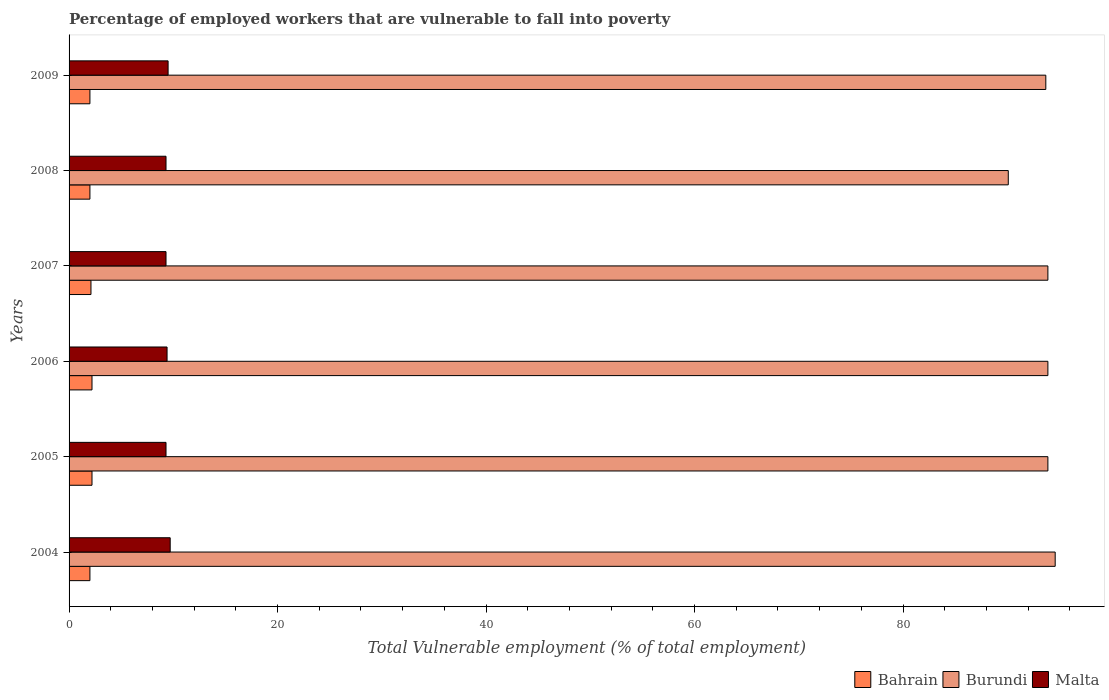How many groups of bars are there?
Your answer should be compact. 6. Are the number of bars on each tick of the Y-axis equal?
Your answer should be compact. Yes. How many bars are there on the 2nd tick from the top?
Provide a succinct answer. 3. How many bars are there on the 3rd tick from the bottom?
Provide a succinct answer. 3. What is the label of the 3rd group of bars from the top?
Offer a very short reply. 2007. In how many cases, is the number of bars for a given year not equal to the number of legend labels?
Provide a succinct answer. 0. Across all years, what is the maximum percentage of employed workers who are vulnerable to fall into poverty in Burundi?
Provide a succinct answer. 94.6. In which year was the percentage of employed workers who are vulnerable to fall into poverty in Malta maximum?
Give a very brief answer. 2004. What is the total percentage of employed workers who are vulnerable to fall into poverty in Malta in the graph?
Offer a very short reply. 56.5. What is the difference between the percentage of employed workers who are vulnerable to fall into poverty in Bahrain in 2008 and that in 2009?
Offer a terse response. 0. What is the difference between the percentage of employed workers who are vulnerable to fall into poverty in Burundi in 2004 and the percentage of employed workers who are vulnerable to fall into poverty in Bahrain in 2005?
Offer a very short reply. 92.4. What is the average percentage of employed workers who are vulnerable to fall into poverty in Malta per year?
Your answer should be compact. 9.42. In the year 2004, what is the difference between the percentage of employed workers who are vulnerable to fall into poverty in Burundi and percentage of employed workers who are vulnerable to fall into poverty in Malta?
Provide a short and direct response. 84.9. What is the ratio of the percentage of employed workers who are vulnerable to fall into poverty in Bahrain in 2004 to that in 2006?
Offer a terse response. 0.91. What is the difference between the highest and the second highest percentage of employed workers who are vulnerable to fall into poverty in Burundi?
Ensure brevity in your answer.  0.7. What is the difference between the highest and the lowest percentage of employed workers who are vulnerable to fall into poverty in Bahrain?
Keep it short and to the point. 0.2. What does the 2nd bar from the top in 2004 represents?
Provide a succinct answer. Burundi. What does the 2nd bar from the bottom in 2006 represents?
Provide a succinct answer. Burundi. How many bars are there?
Give a very brief answer. 18. How many years are there in the graph?
Your answer should be compact. 6. Are the values on the major ticks of X-axis written in scientific E-notation?
Provide a short and direct response. No. Does the graph contain any zero values?
Make the answer very short. No. What is the title of the graph?
Your response must be concise. Percentage of employed workers that are vulnerable to fall into poverty. Does "United Arab Emirates" appear as one of the legend labels in the graph?
Keep it short and to the point. No. What is the label or title of the X-axis?
Offer a very short reply. Total Vulnerable employment (% of total employment). What is the Total Vulnerable employment (% of total employment) of Burundi in 2004?
Provide a succinct answer. 94.6. What is the Total Vulnerable employment (% of total employment) in Malta in 2004?
Offer a terse response. 9.7. What is the Total Vulnerable employment (% of total employment) in Bahrain in 2005?
Provide a succinct answer. 2.2. What is the Total Vulnerable employment (% of total employment) in Burundi in 2005?
Your response must be concise. 93.9. What is the Total Vulnerable employment (% of total employment) in Malta in 2005?
Your answer should be compact. 9.3. What is the Total Vulnerable employment (% of total employment) in Bahrain in 2006?
Your answer should be very brief. 2.2. What is the Total Vulnerable employment (% of total employment) in Burundi in 2006?
Ensure brevity in your answer.  93.9. What is the Total Vulnerable employment (% of total employment) of Malta in 2006?
Provide a succinct answer. 9.4. What is the Total Vulnerable employment (% of total employment) in Bahrain in 2007?
Give a very brief answer. 2.1. What is the Total Vulnerable employment (% of total employment) of Burundi in 2007?
Ensure brevity in your answer.  93.9. What is the Total Vulnerable employment (% of total employment) in Malta in 2007?
Make the answer very short. 9.3. What is the Total Vulnerable employment (% of total employment) in Burundi in 2008?
Make the answer very short. 90.1. What is the Total Vulnerable employment (% of total employment) in Malta in 2008?
Provide a succinct answer. 9.3. What is the Total Vulnerable employment (% of total employment) of Burundi in 2009?
Your response must be concise. 93.7. What is the Total Vulnerable employment (% of total employment) of Malta in 2009?
Your answer should be compact. 9.5. Across all years, what is the maximum Total Vulnerable employment (% of total employment) of Bahrain?
Provide a short and direct response. 2.2. Across all years, what is the maximum Total Vulnerable employment (% of total employment) in Burundi?
Provide a short and direct response. 94.6. Across all years, what is the maximum Total Vulnerable employment (% of total employment) of Malta?
Provide a succinct answer. 9.7. Across all years, what is the minimum Total Vulnerable employment (% of total employment) in Bahrain?
Your answer should be compact. 2. Across all years, what is the minimum Total Vulnerable employment (% of total employment) of Burundi?
Give a very brief answer. 90.1. Across all years, what is the minimum Total Vulnerable employment (% of total employment) of Malta?
Offer a terse response. 9.3. What is the total Total Vulnerable employment (% of total employment) in Burundi in the graph?
Offer a very short reply. 560.1. What is the total Total Vulnerable employment (% of total employment) of Malta in the graph?
Keep it short and to the point. 56.5. What is the difference between the Total Vulnerable employment (% of total employment) of Bahrain in 2004 and that in 2005?
Provide a succinct answer. -0.2. What is the difference between the Total Vulnerable employment (% of total employment) in Bahrain in 2004 and that in 2006?
Keep it short and to the point. -0.2. What is the difference between the Total Vulnerable employment (% of total employment) in Bahrain in 2004 and that in 2007?
Your answer should be very brief. -0.1. What is the difference between the Total Vulnerable employment (% of total employment) of Malta in 2004 and that in 2007?
Keep it short and to the point. 0.4. What is the difference between the Total Vulnerable employment (% of total employment) of Bahrain in 2004 and that in 2008?
Your answer should be very brief. 0. What is the difference between the Total Vulnerable employment (% of total employment) in Burundi in 2004 and that in 2008?
Provide a short and direct response. 4.5. What is the difference between the Total Vulnerable employment (% of total employment) in Malta in 2004 and that in 2008?
Provide a succinct answer. 0.4. What is the difference between the Total Vulnerable employment (% of total employment) in Bahrain in 2004 and that in 2009?
Offer a terse response. 0. What is the difference between the Total Vulnerable employment (% of total employment) of Burundi in 2004 and that in 2009?
Keep it short and to the point. 0.9. What is the difference between the Total Vulnerable employment (% of total employment) in Malta in 2004 and that in 2009?
Your answer should be very brief. 0.2. What is the difference between the Total Vulnerable employment (% of total employment) in Malta in 2005 and that in 2006?
Your answer should be compact. -0.1. What is the difference between the Total Vulnerable employment (% of total employment) in Bahrain in 2005 and that in 2008?
Make the answer very short. 0.2. What is the difference between the Total Vulnerable employment (% of total employment) in Burundi in 2005 and that in 2008?
Give a very brief answer. 3.8. What is the difference between the Total Vulnerable employment (% of total employment) of Malta in 2005 and that in 2008?
Your answer should be very brief. 0. What is the difference between the Total Vulnerable employment (% of total employment) of Burundi in 2006 and that in 2007?
Your response must be concise. 0. What is the difference between the Total Vulnerable employment (% of total employment) in Burundi in 2006 and that in 2008?
Ensure brevity in your answer.  3.8. What is the difference between the Total Vulnerable employment (% of total employment) of Bahrain in 2007 and that in 2008?
Provide a succinct answer. 0.1. What is the difference between the Total Vulnerable employment (% of total employment) of Burundi in 2007 and that in 2008?
Provide a succinct answer. 3.8. What is the difference between the Total Vulnerable employment (% of total employment) in Malta in 2007 and that in 2008?
Your answer should be very brief. 0. What is the difference between the Total Vulnerable employment (% of total employment) of Burundi in 2007 and that in 2009?
Offer a very short reply. 0.2. What is the difference between the Total Vulnerable employment (% of total employment) in Malta in 2008 and that in 2009?
Make the answer very short. -0.2. What is the difference between the Total Vulnerable employment (% of total employment) in Bahrain in 2004 and the Total Vulnerable employment (% of total employment) in Burundi in 2005?
Offer a terse response. -91.9. What is the difference between the Total Vulnerable employment (% of total employment) of Bahrain in 2004 and the Total Vulnerable employment (% of total employment) of Malta in 2005?
Give a very brief answer. -7.3. What is the difference between the Total Vulnerable employment (% of total employment) in Burundi in 2004 and the Total Vulnerable employment (% of total employment) in Malta in 2005?
Keep it short and to the point. 85.3. What is the difference between the Total Vulnerable employment (% of total employment) in Bahrain in 2004 and the Total Vulnerable employment (% of total employment) in Burundi in 2006?
Your answer should be compact. -91.9. What is the difference between the Total Vulnerable employment (% of total employment) in Burundi in 2004 and the Total Vulnerable employment (% of total employment) in Malta in 2006?
Keep it short and to the point. 85.2. What is the difference between the Total Vulnerable employment (% of total employment) in Bahrain in 2004 and the Total Vulnerable employment (% of total employment) in Burundi in 2007?
Provide a short and direct response. -91.9. What is the difference between the Total Vulnerable employment (% of total employment) of Bahrain in 2004 and the Total Vulnerable employment (% of total employment) of Malta in 2007?
Make the answer very short. -7.3. What is the difference between the Total Vulnerable employment (% of total employment) of Burundi in 2004 and the Total Vulnerable employment (% of total employment) of Malta in 2007?
Your response must be concise. 85.3. What is the difference between the Total Vulnerable employment (% of total employment) of Bahrain in 2004 and the Total Vulnerable employment (% of total employment) of Burundi in 2008?
Ensure brevity in your answer.  -88.1. What is the difference between the Total Vulnerable employment (% of total employment) in Bahrain in 2004 and the Total Vulnerable employment (% of total employment) in Malta in 2008?
Offer a terse response. -7.3. What is the difference between the Total Vulnerable employment (% of total employment) in Burundi in 2004 and the Total Vulnerable employment (% of total employment) in Malta in 2008?
Ensure brevity in your answer.  85.3. What is the difference between the Total Vulnerable employment (% of total employment) in Bahrain in 2004 and the Total Vulnerable employment (% of total employment) in Burundi in 2009?
Offer a very short reply. -91.7. What is the difference between the Total Vulnerable employment (% of total employment) of Bahrain in 2004 and the Total Vulnerable employment (% of total employment) of Malta in 2009?
Ensure brevity in your answer.  -7.5. What is the difference between the Total Vulnerable employment (% of total employment) in Burundi in 2004 and the Total Vulnerable employment (% of total employment) in Malta in 2009?
Give a very brief answer. 85.1. What is the difference between the Total Vulnerable employment (% of total employment) of Bahrain in 2005 and the Total Vulnerable employment (% of total employment) of Burundi in 2006?
Offer a terse response. -91.7. What is the difference between the Total Vulnerable employment (% of total employment) of Bahrain in 2005 and the Total Vulnerable employment (% of total employment) of Malta in 2006?
Keep it short and to the point. -7.2. What is the difference between the Total Vulnerable employment (% of total employment) in Burundi in 2005 and the Total Vulnerable employment (% of total employment) in Malta in 2006?
Your answer should be very brief. 84.5. What is the difference between the Total Vulnerable employment (% of total employment) in Bahrain in 2005 and the Total Vulnerable employment (% of total employment) in Burundi in 2007?
Offer a very short reply. -91.7. What is the difference between the Total Vulnerable employment (% of total employment) of Burundi in 2005 and the Total Vulnerable employment (% of total employment) of Malta in 2007?
Keep it short and to the point. 84.6. What is the difference between the Total Vulnerable employment (% of total employment) of Bahrain in 2005 and the Total Vulnerable employment (% of total employment) of Burundi in 2008?
Your answer should be compact. -87.9. What is the difference between the Total Vulnerable employment (% of total employment) of Bahrain in 2005 and the Total Vulnerable employment (% of total employment) of Malta in 2008?
Provide a short and direct response. -7.1. What is the difference between the Total Vulnerable employment (% of total employment) of Burundi in 2005 and the Total Vulnerable employment (% of total employment) of Malta in 2008?
Provide a succinct answer. 84.6. What is the difference between the Total Vulnerable employment (% of total employment) in Bahrain in 2005 and the Total Vulnerable employment (% of total employment) in Burundi in 2009?
Offer a very short reply. -91.5. What is the difference between the Total Vulnerable employment (% of total employment) of Burundi in 2005 and the Total Vulnerable employment (% of total employment) of Malta in 2009?
Ensure brevity in your answer.  84.4. What is the difference between the Total Vulnerable employment (% of total employment) in Bahrain in 2006 and the Total Vulnerable employment (% of total employment) in Burundi in 2007?
Keep it short and to the point. -91.7. What is the difference between the Total Vulnerable employment (% of total employment) of Burundi in 2006 and the Total Vulnerable employment (% of total employment) of Malta in 2007?
Offer a very short reply. 84.6. What is the difference between the Total Vulnerable employment (% of total employment) of Bahrain in 2006 and the Total Vulnerable employment (% of total employment) of Burundi in 2008?
Provide a short and direct response. -87.9. What is the difference between the Total Vulnerable employment (% of total employment) of Bahrain in 2006 and the Total Vulnerable employment (% of total employment) of Malta in 2008?
Provide a succinct answer. -7.1. What is the difference between the Total Vulnerable employment (% of total employment) in Burundi in 2006 and the Total Vulnerable employment (% of total employment) in Malta in 2008?
Keep it short and to the point. 84.6. What is the difference between the Total Vulnerable employment (% of total employment) in Bahrain in 2006 and the Total Vulnerable employment (% of total employment) in Burundi in 2009?
Provide a succinct answer. -91.5. What is the difference between the Total Vulnerable employment (% of total employment) in Burundi in 2006 and the Total Vulnerable employment (% of total employment) in Malta in 2009?
Ensure brevity in your answer.  84.4. What is the difference between the Total Vulnerable employment (% of total employment) of Bahrain in 2007 and the Total Vulnerable employment (% of total employment) of Burundi in 2008?
Your answer should be very brief. -88. What is the difference between the Total Vulnerable employment (% of total employment) in Burundi in 2007 and the Total Vulnerable employment (% of total employment) in Malta in 2008?
Your answer should be very brief. 84.6. What is the difference between the Total Vulnerable employment (% of total employment) of Bahrain in 2007 and the Total Vulnerable employment (% of total employment) of Burundi in 2009?
Offer a very short reply. -91.6. What is the difference between the Total Vulnerable employment (% of total employment) of Burundi in 2007 and the Total Vulnerable employment (% of total employment) of Malta in 2009?
Ensure brevity in your answer.  84.4. What is the difference between the Total Vulnerable employment (% of total employment) of Bahrain in 2008 and the Total Vulnerable employment (% of total employment) of Burundi in 2009?
Your answer should be compact. -91.7. What is the difference between the Total Vulnerable employment (% of total employment) in Bahrain in 2008 and the Total Vulnerable employment (% of total employment) in Malta in 2009?
Give a very brief answer. -7.5. What is the difference between the Total Vulnerable employment (% of total employment) in Burundi in 2008 and the Total Vulnerable employment (% of total employment) in Malta in 2009?
Your answer should be very brief. 80.6. What is the average Total Vulnerable employment (% of total employment) of Bahrain per year?
Ensure brevity in your answer.  2.08. What is the average Total Vulnerable employment (% of total employment) of Burundi per year?
Keep it short and to the point. 93.35. What is the average Total Vulnerable employment (% of total employment) in Malta per year?
Offer a very short reply. 9.42. In the year 2004, what is the difference between the Total Vulnerable employment (% of total employment) in Bahrain and Total Vulnerable employment (% of total employment) in Burundi?
Provide a short and direct response. -92.6. In the year 2004, what is the difference between the Total Vulnerable employment (% of total employment) in Burundi and Total Vulnerable employment (% of total employment) in Malta?
Offer a very short reply. 84.9. In the year 2005, what is the difference between the Total Vulnerable employment (% of total employment) in Bahrain and Total Vulnerable employment (% of total employment) in Burundi?
Keep it short and to the point. -91.7. In the year 2005, what is the difference between the Total Vulnerable employment (% of total employment) in Bahrain and Total Vulnerable employment (% of total employment) in Malta?
Keep it short and to the point. -7.1. In the year 2005, what is the difference between the Total Vulnerable employment (% of total employment) of Burundi and Total Vulnerable employment (% of total employment) of Malta?
Ensure brevity in your answer.  84.6. In the year 2006, what is the difference between the Total Vulnerable employment (% of total employment) in Bahrain and Total Vulnerable employment (% of total employment) in Burundi?
Offer a terse response. -91.7. In the year 2006, what is the difference between the Total Vulnerable employment (% of total employment) in Bahrain and Total Vulnerable employment (% of total employment) in Malta?
Your answer should be very brief. -7.2. In the year 2006, what is the difference between the Total Vulnerable employment (% of total employment) in Burundi and Total Vulnerable employment (% of total employment) in Malta?
Your response must be concise. 84.5. In the year 2007, what is the difference between the Total Vulnerable employment (% of total employment) of Bahrain and Total Vulnerable employment (% of total employment) of Burundi?
Provide a succinct answer. -91.8. In the year 2007, what is the difference between the Total Vulnerable employment (% of total employment) of Bahrain and Total Vulnerable employment (% of total employment) of Malta?
Offer a terse response. -7.2. In the year 2007, what is the difference between the Total Vulnerable employment (% of total employment) of Burundi and Total Vulnerable employment (% of total employment) of Malta?
Offer a very short reply. 84.6. In the year 2008, what is the difference between the Total Vulnerable employment (% of total employment) in Bahrain and Total Vulnerable employment (% of total employment) in Burundi?
Give a very brief answer. -88.1. In the year 2008, what is the difference between the Total Vulnerable employment (% of total employment) in Burundi and Total Vulnerable employment (% of total employment) in Malta?
Provide a succinct answer. 80.8. In the year 2009, what is the difference between the Total Vulnerable employment (% of total employment) of Bahrain and Total Vulnerable employment (% of total employment) of Burundi?
Provide a short and direct response. -91.7. In the year 2009, what is the difference between the Total Vulnerable employment (% of total employment) in Bahrain and Total Vulnerable employment (% of total employment) in Malta?
Keep it short and to the point. -7.5. In the year 2009, what is the difference between the Total Vulnerable employment (% of total employment) of Burundi and Total Vulnerable employment (% of total employment) of Malta?
Make the answer very short. 84.2. What is the ratio of the Total Vulnerable employment (% of total employment) of Burundi in 2004 to that in 2005?
Provide a short and direct response. 1.01. What is the ratio of the Total Vulnerable employment (% of total employment) of Malta in 2004 to that in 2005?
Keep it short and to the point. 1.04. What is the ratio of the Total Vulnerable employment (% of total employment) of Bahrain in 2004 to that in 2006?
Offer a very short reply. 0.91. What is the ratio of the Total Vulnerable employment (% of total employment) in Burundi in 2004 to that in 2006?
Offer a terse response. 1.01. What is the ratio of the Total Vulnerable employment (% of total employment) in Malta in 2004 to that in 2006?
Make the answer very short. 1.03. What is the ratio of the Total Vulnerable employment (% of total employment) of Burundi in 2004 to that in 2007?
Your answer should be very brief. 1.01. What is the ratio of the Total Vulnerable employment (% of total employment) in Malta in 2004 to that in 2007?
Your answer should be very brief. 1.04. What is the ratio of the Total Vulnerable employment (% of total employment) in Burundi in 2004 to that in 2008?
Offer a very short reply. 1.05. What is the ratio of the Total Vulnerable employment (% of total employment) of Malta in 2004 to that in 2008?
Give a very brief answer. 1.04. What is the ratio of the Total Vulnerable employment (% of total employment) in Burundi in 2004 to that in 2009?
Provide a short and direct response. 1.01. What is the ratio of the Total Vulnerable employment (% of total employment) in Malta in 2004 to that in 2009?
Offer a very short reply. 1.02. What is the ratio of the Total Vulnerable employment (% of total employment) in Bahrain in 2005 to that in 2006?
Your answer should be compact. 1. What is the ratio of the Total Vulnerable employment (% of total employment) in Bahrain in 2005 to that in 2007?
Ensure brevity in your answer.  1.05. What is the ratio of the Total Vulnerable employment (% of total employment) in Burundi in 2005 to that in 2007?
Your answer should be very brief. 1. What is the ratio of the Total Vulnerable employment (% of total employment) of Malta in 2005 to that in 2007?
Keep it short and to the point. 1. What is the ratio of the Total Vulnerable employment (% of total employment) of Burundi in 2005 to that in 2008?
Ensure brevity in your answer.  1.04. What is the ratio of the Total Vulnerable employment (% of total employment) of Bahrain in 2005 to that in 2009?
Your response must be concise. 1.1. What is the ratio of the Total Vulnerable employment (% of total employment) of Burundi in 2005 to that in 2009?
Provide a succinct answer. 1. What is the ratio of the Total Vulnerable employment (% of total employment) in Malta in 2005 to that in 2009?
Give a very brief answer. 0.98. What is the ratio of the Total Vulnerable employment (% of total employment) in Bahrain in 2006 to that in 2007?
Offer a very short reply. 1.05. What is the ratio of the Total Vulnerable employment (% of total employment) in Burundi in 2006 to that in 2007?
Ensure brevity in your answer.  1. What is the ratio of the Total Vulnerable employment (% of total employment) in Malta in 2006 to that in 2007?
Give a very brief answer. 1.01. What is the ratio of the Total Vulnerable employment (% of total employment) in Burundi in 2006 to that in 2008?
Your answer should be very brief. 1.04. What is the ratio of the Total Vulnerable employment (% of total employment) of Malta in 2006 to that in 2008?
Keep it short and to the point. 1.01. What is the ratio of the Total Vulnerable employment (% of total employment) in Burundi in 2006 to that in 2009?
Offer a very short reply. 1. What is the ratio of the Total Vulnerable employment (% of total employment) in Burundi in 2007 to that in 2008?
Offer a very short reply. 1.04. What is the ratio of the Total Vulnerable employment (% of total employment) of Bahrain in 2007 to that in 2009?
Your answer should be very brief. 1.05. What is the ratio of the Total Vulnerable employment (% of total employment) of Burundi in 2007 to that in 2009?
Offer a very short reply. 1. What is the ratio of the Total Vulnerable employment (% of total employment) of Malta in 2007 to that in 2009?
Provide a short and direct response. 0.98. What is the ratio of the Total Vulnerable employment (% of total employment) of Bahrain in 2008 to that in 2009?
Provide a succinct answer. 1. What is the ratio of the Total Vulnerable employment (% of total employment) in Burundi in 2008 to that in 2009?
Provide a short and direct response. 0.96. What is the ratio of the Total Vulnerable employment (% of total employment) in Malta in 2008 to that in 2009?
Your answer should be very brief. 0.98. What is the difference between the highest and the second highest Total Vulnerable employment (% of total employment) in Malta?
Provide a succinct answer. 0.2. What is the difference between the highest and the lowest Total Vulnerable employment (% of total employment) of Bahrain?
Make the answer very short. 0.2. What is the difference between the highest and the lowest Total Vulnerable employment (% of total employment) in Burundi?
Keep it short and to the point. 4.5. 